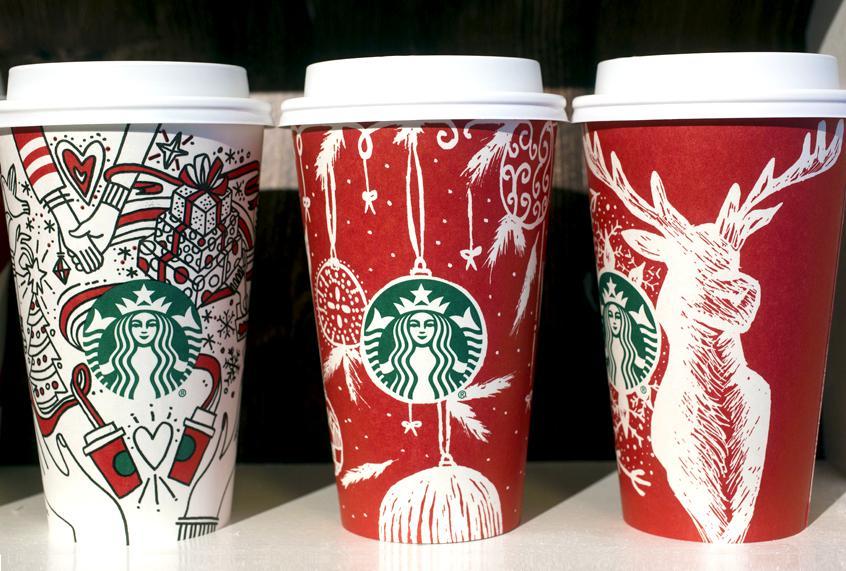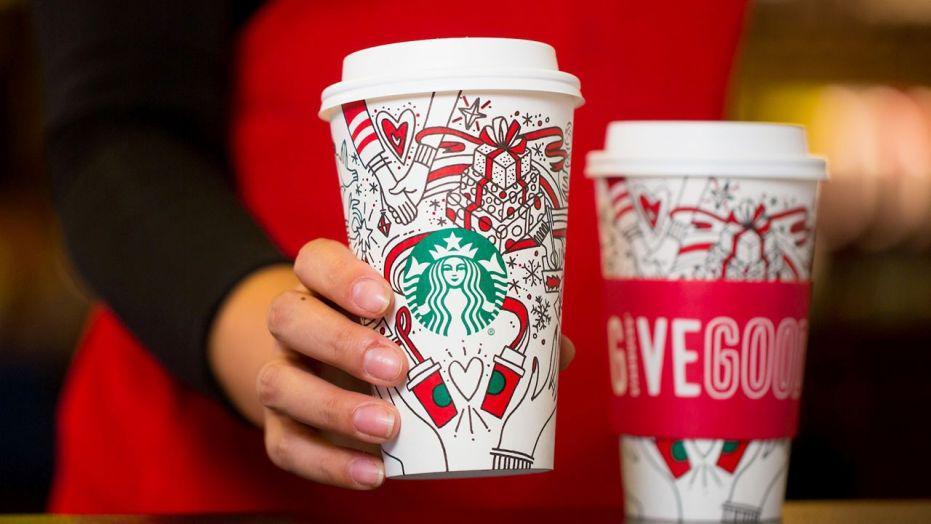The first image is the image on the left, the second image is the image on the right. Assess this claim about the two images: "In both images a person is holding a cup in their hand.". Correct or not? Answer yes or no. No. 